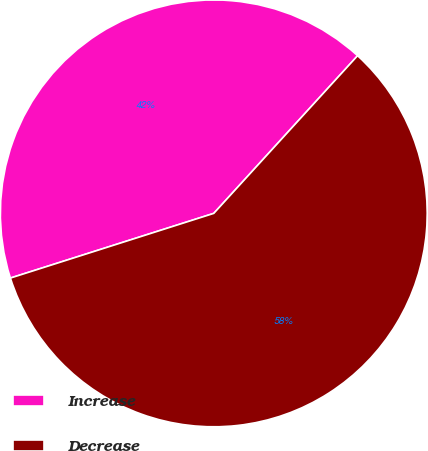Convert chart to OTSL. <chart><loc_0><loc_0><loc_500><loc_500><pie_chart><fcel>Increase<fcel>Decrease<nl><fcel>41.67%<fcel>58.33%<nl></chart> 